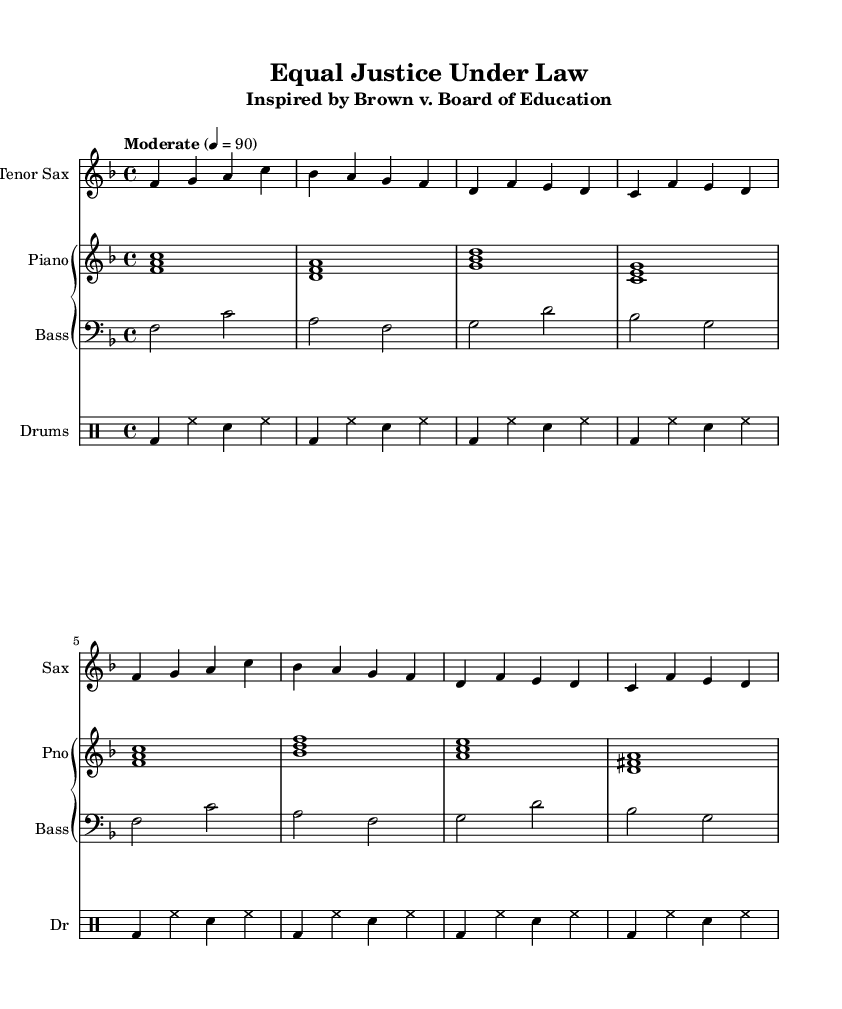What is the key signature of this music? The key signature is F major, which has one flat noted on the staff.
Answer: F major What is the time signature of the piece? The time signature is indicated at the beginning of the sheet music as 4/4, meaning four beats per measure.
Answer: 4/4 What is the tempo marking used in the composition? The tempo marking is "Moderate," with a specific metronome marking of 90 beats per minute.
Answer: Moderate How many measures are in the saxophone part? The saxophone part consists of a total of eight measures, as counted from the beginning to the end of the provided music.
Answer: Eight measures Which Supreme Court case inspired this composition? The composition is inspired by Brown v. Board of Education, as indicated in the subtitle of the sheet music.
Answer: Brown v. Board of Education What instruments are included in this score? The score includes a tenor saxophone, piano, bass, and drums, as exhibited by the separate parts listed in the music.
Answer: Tenor saxophone, piano, bass, drums How many times does the main saxophone theme repeat in the provided part? The saxophone theme repeats two times in the score, as shown by the similar sequences of notes in the measures.
Answer: Two times 